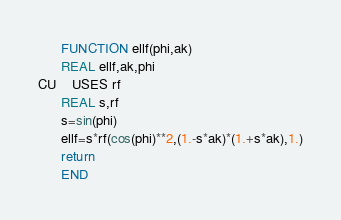Convert code to text. <code><loc_0><loc_0><loc_500><loc_500><_FORTRAN_>      FUNCTION ellf(phi,ak)
      REAL ellf,ak,phi
CU    USES rf
      REAL s,rf
      s=sin(phi)
      ellf=s*rf(cos(phi)**2,(1.-s*ak)*(1.+s*ak),1.)
      return
      END
</code> 